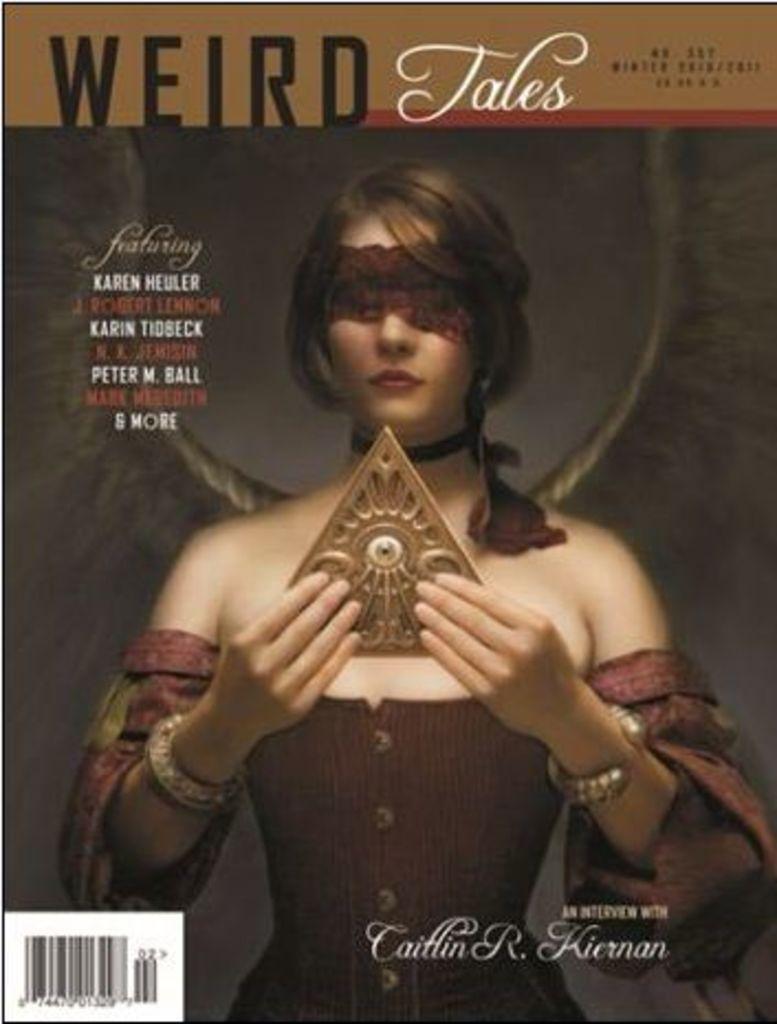What is the name of this magazine?
Keep it short and to the point. Weird tales. 